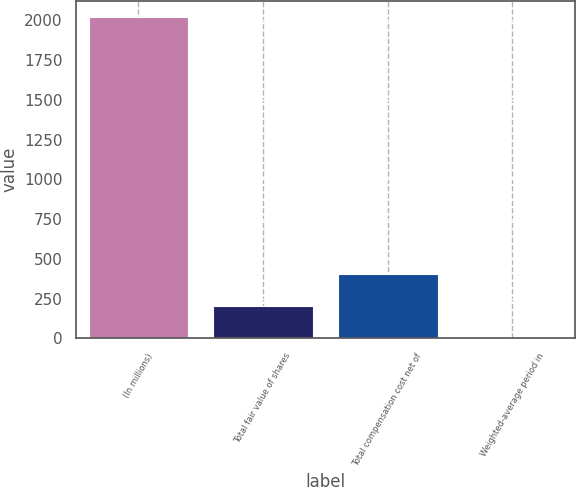<chart> <loc_0><loc_0><loc_500><loc_500><bar_chart><fcel>(In millions)<fcel>Total fair value of shares<fcel>Total compensation cost net of<fcel>Weighted-average period in<nl><fcel>2019<fcel>203.7<fcel>405.4<fcel>2<nl></chart> 